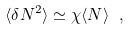Convert formula to latex. <formula><loc_0><loc_0><loc_500><loc_500>\langle \delta N ^ { 2 } \rangle \simeq \chi \langle N \rangle \ ,</formula> 